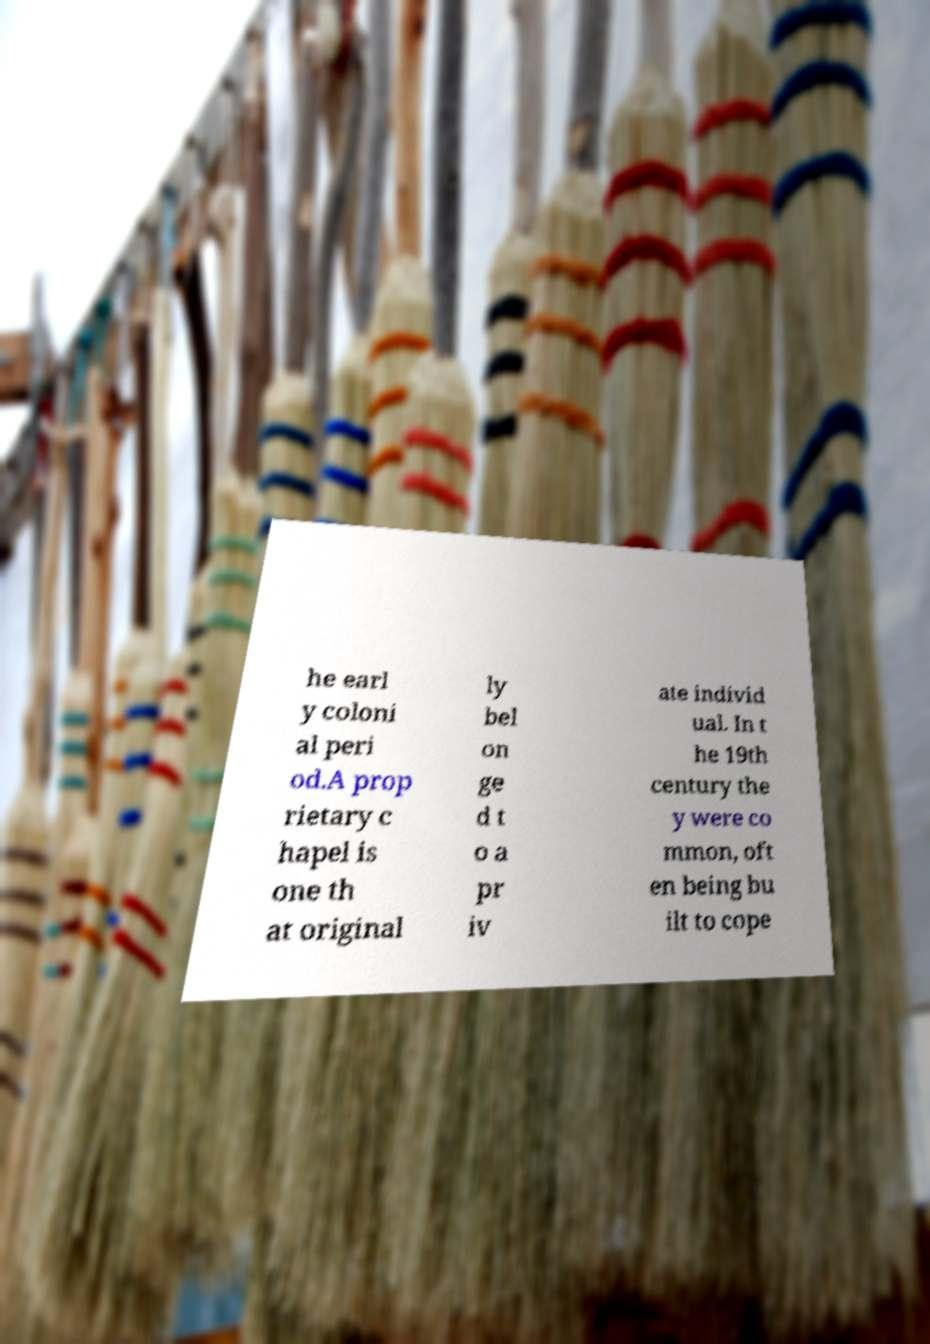There's text embedded in this image that I need extracted. Can you transcribe it verbatim? he earl y coloni al peri od.A prop rietary c hapel is one th at original ly bel on ge d t o a pr iv ate individ ual. In t he 19th century the y were co mmon, oft en being bu ilt to cope 